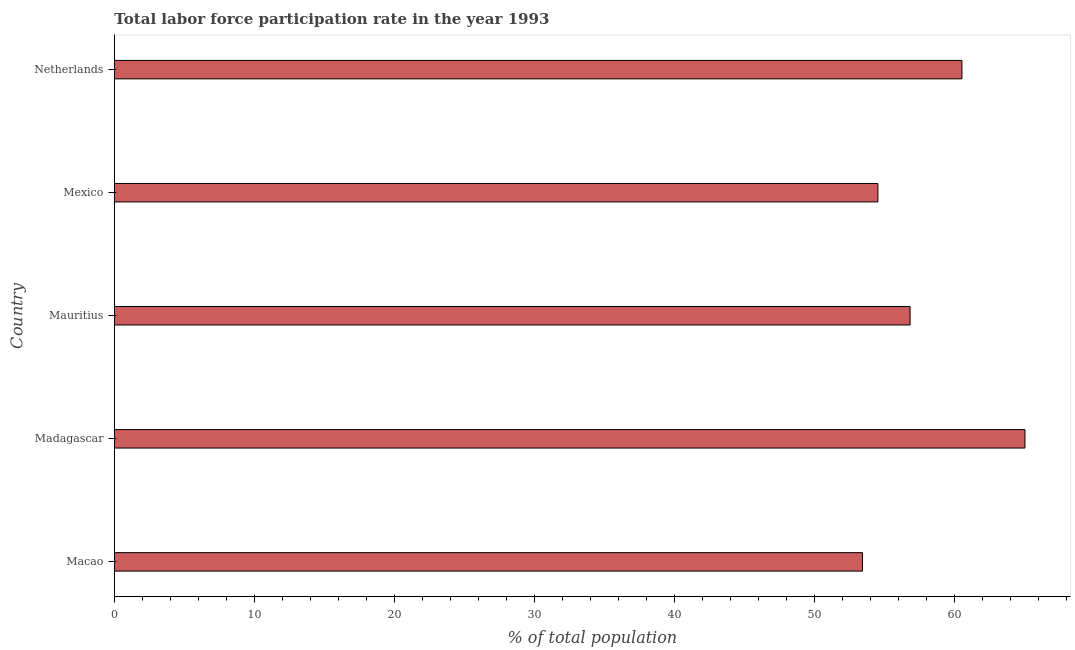Does the graph contain grids?
Your response must be concise. No. What is the title of the graph?
Keep it short and to the point. Total labor force participation rate in the year 1993. What is the label or title of the X-axis?
Offer a terse response. % of total population. What is the total labor force participation rate in Mauritius?
Keep it short and to the point. 56.8. Across all countries, what is the minimum total labor force participation rate?
Provide a succinct answer. 53.4. In which country was the total labor force participation rate maximum?
Make the answer very short. Madagascar. In which country was the total labor force participation rate minimum?
Ensure brevity in your answer.  Macao. What is the sum of the total labor force participation rate?
Make the answer very short. 290.2. What is the average total labor force participation rate per country?
Provide a short and direct response. 58.04. What is the median total labor force participation rate?
Make the answer very short. 56.8. What is the ratio of the total labor force participation rate in Madagascar to that in Mauritius?
Make the answer very short. 1.14. Is the total labor force participation rate in Mauritius less than that in Netherlands?
Offer a terse response. Yes. Is the sum of the total labor force participation rate in Macao and Madagascar greater than the maximum total labor force participation rate across all countries?
Keep it short and to the point. Yes. What is the difference between the highest and the lowest total labor force participation rate?
Your answer should be very brief. 11.6. How many bars are there?
Give a very brief answer. 5. Are all the bars in the graph horizontal?
Make the answer very short. Yes. Are the values on the major ticks of X-axis written in scientific E-notation?
Your answer should be compact. No. What is the % of total population of Macao?
Ensure brevity in your answer.  53.4. What is the % of total population of Madagascar?
Keep it short and to the point. 65. What is the % of total population in Mauritius?
Give a very brief answer. 56.8. What is the % of total population of Mexico?
Make the answer very short. 54.5. What is the % of total population of Netherlands?
Your response must be concise. 60.5. What is the difference between the % of total population in Macao and Madagascar?
Keep it short and to the point. -11.6. What is the difference between the % of total population in Macao and Mauritius?
Provide a succinct answer. -3.4. What is the difference between the % of total population in Macao and Netherlands?
Ensure brevity in your answer.  -7.1. What is the difference between the % of total population in Madagascar and Mexico?
Your answer should be compact. 10.5. What is the difference between the % of total population in Mauritius and Mexico?
Your answer should be compact. 2.3. What is the ratio of the % of total population in Macao to that in Madagascar?
Ensure brevity in your answer.  0.82. What is the ratio of the % of total population in Macao to that in Mexico?
Offer a terse response. 0.98. What is the ratio of the % of total population in Macao to that in Netherlands?
Provide a succinct answer. 0.88. What is the ratio of the % of total population in Madagascar to that in Mauritius?
Give a very brief answer. 1.14. What is the ratio of the % of total population in Madagascar to that in Mexico?
Ensure brevity in your answer.  1.19. What is the ratio of the % of total population in Madagascar to that in Netherlands?
Provide a short and direct response. 1.07. What is the ratio of the % of total population in Mauritius to that in Mexico?
Your answer should be compact. 1.04. What is the ratio of the % of total population in Mauritius to that in Netherlands?
Your response must be concise. 0.94. What is the ratio of the % of total population in Mexico to that in Netherlands?
Ensure brevity in your answer.  0.9. 